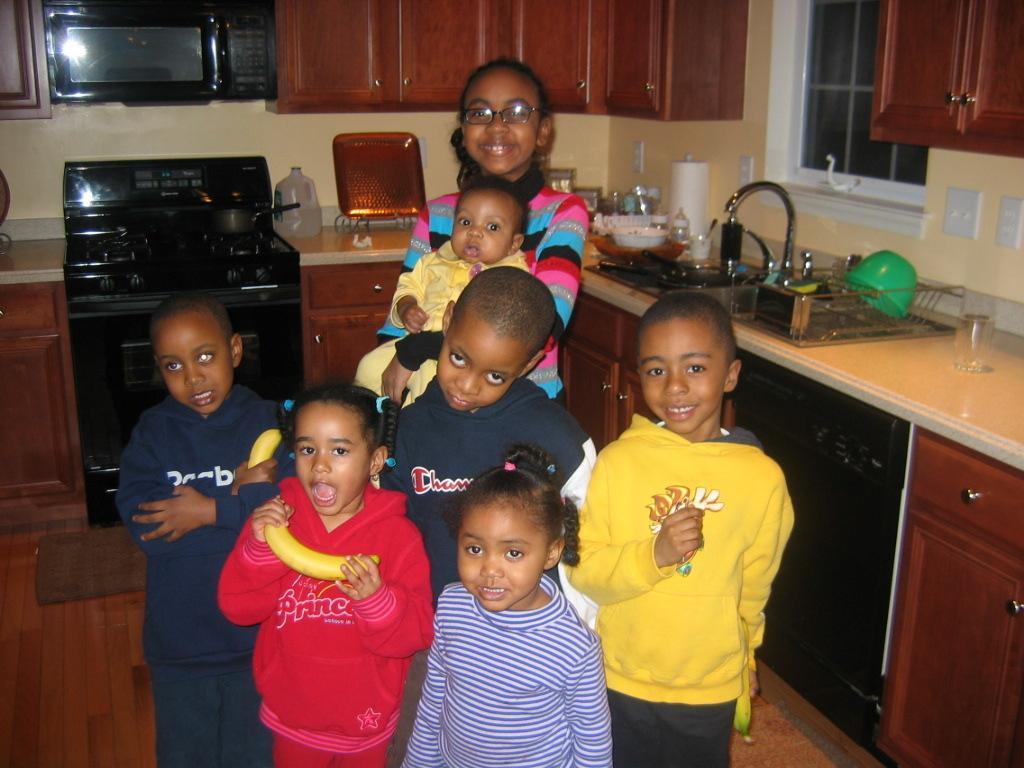Could you give a brief overview of what you see in this image? In the foreground of this image, there are girls and boys standing on the floor and few are holding bananas in their hands. Behind them, there is a girl carrying a baby. In the background, on the kitchen slab, there is a glass, a bowl stand, sink, a can, stove on which there is a vessel and few more objects. At the top, there are wooden cupboards, a microwave oven and a glass window. 